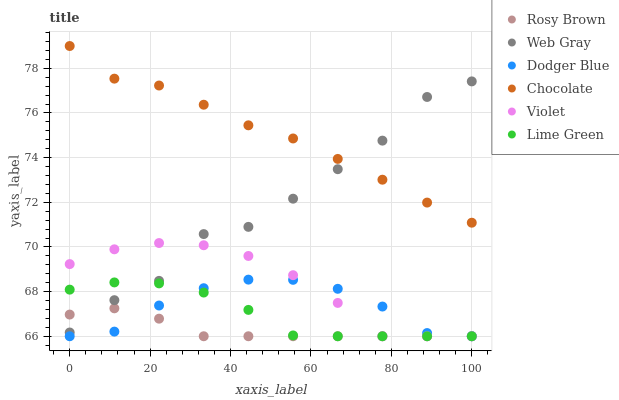Does Rosy Brown have the minimum area under the curve?
Answer yes or no. Yes. Does Chocolate have the maximum area under the curve?
Answer yes or no. Yes. Does Chocolate have the minimum area under the curve?
Answer yes or no. No. Does Rosy Brown have the maximum area under the curve?
Answer yes or no. No. Is Rosy Brown the smoothest?
Answer yes or no. Yes. Is Web Gray the roughest?
Answer yes or no. Yes. Is Chocolate the smoothest?
Answer yes or no. No. Is Chocolate the roughest?
Answer yes or no. No. Does Rosy Brown have the lowest value?
Answer yes or no. Yes. Does Chocolate have the lowest value?
Answer yes or no. No. Does Chocolate have the highest value?
Answer yes or no. Yes. Does Rosy Brown have the highest value?
Answer yes or no. No. Is Dodger Blue less than Chocolate?
Answer yes or no. Yes. Is Chocolate greater than Lime Green?
Answer yes or no. Yes. Does Lime Green intersect Rosy Brown?
Answer yes or no. Yes. Is Lime Green less than Rosy Brown?
Answer yes or no. No. Is Lime Green greater than Rosy Brown?
Answer yes or no. No. Does Dodger Blue intersect Chocolate?
Answer yes or no. No. 